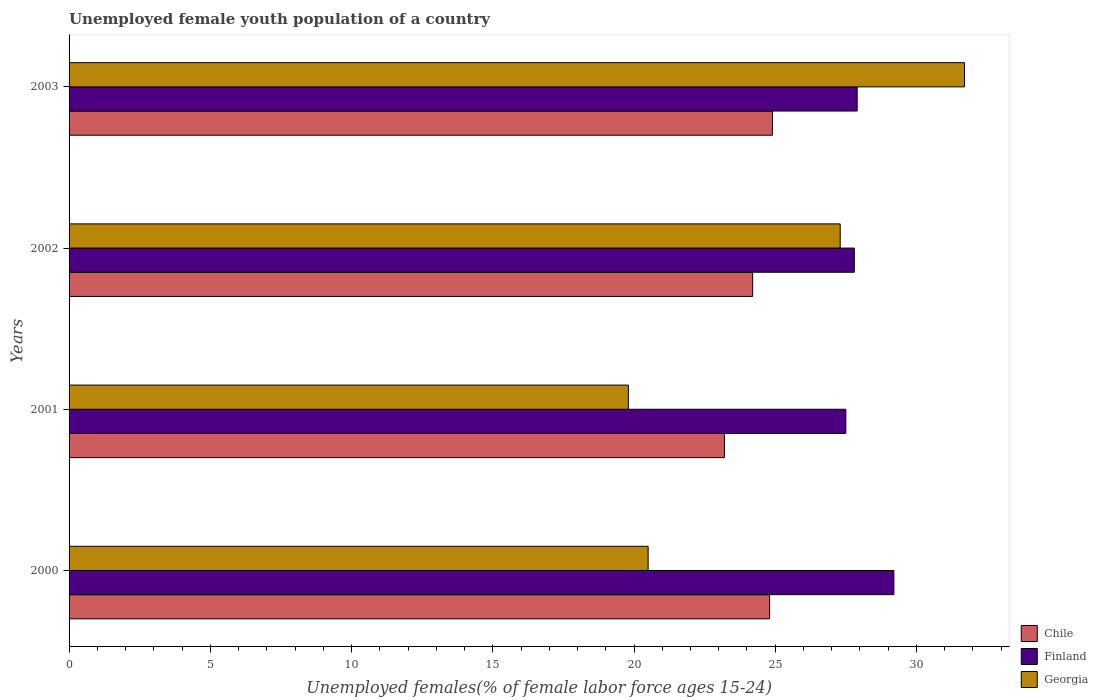How many different coloured bars are there?
Your answer should be compact. 3. How many groups of bars are there?
Ensure brevity in your answer.  4. Are the number of bars per tick equal to the number of legend labels?
Your response must be concise. Yes. In how many cases, is the number of bars for a given year not equal to the number of legend labels?
Provide a short and direct response. 0. What is the percentage of unemployed female youth population in Georgia in 2003?
Provide a succinct answer. 31.7. Across all years, what is the maximum percentage of unemployed female youth population in Finland?
Make the answer very short. 29.2. In which year was the percentage of unemployed female youth population in Chile maximum?
Your answer should be compact. 2003. In which year was the percentage of unemployed female youth population in Chile minimum?
Provide a succinct answer. 2001. What is the total percentage of unemployed female youth population in Chile in the graph?
Your answer should be very brief. 97.1. What is the difference between the percentage of unemployed female youth population in Georgia in 2000 and that in 2001?
Your response must be concise. 0.7. What is the difference between the percentage of unemployed female youth population in Finland in 2000 and the percentage of unemployed female youth population in Georgia in 2001?
Give a very brief answer. 9.4. What is the average percentage of unemployed female youth population in Finland per year?
Your answer should be compact. 28.1. In the year 2001, what is the difference between the percentage of unemployed female youth population in Georgia and percentage of unemployed female youth population in Finland?
Your answer should be compact. -7.7. In how many years, is the percentage of unemployed female youth population in Finland greater than 21 %?
Keep it short and to the point. 4. What is the ratio of the percentage of unemployed female youth population in Georgia in 2000 to that in 2002?
Keep it short and to the point. 0.75. Is the difference between the percentage of unemployed female youth population in Georgia in 2001 and 2003 greater than the difference between the percentage of unemployed female youth population in Finland in 2001 and 2003?
Keep it short and to the point. No. What is the difference between the highest and the second highest percentage of unemployed female youth population in Georgia?
Your answer should be compact. 4.4. What is the difference between the highest and the lowest percentage of unemployed female youth population in Finland?
Ensure brevity in your answer.  1.7. Is the sum of the percentage of unemployed female youth population in Chile in 2002 and 2003 greater than the maximum percentage of unemployed female youth population in Finland across all years?
Give a very brief answer. Yes. What does the 2nd bar from the top in 2002 represents?
Make the answer very short. Finland. Are all the bars in the graph horizontal?
Give a very brief answer. Yes. What is the difference between two consecutive major ticks on the X-axis?
Ensure brevity in your answer.  5. Where does the legend appear in the graph?
Make the answer very short. Bottom right. How many legend labels are there?
Your answer should be very brief. 3. What is the title of the graph?
Offer a very short reply. Unemployed female youth population of a country. Does "Middle East & North Africa (all income levels)" appear as one of the legend labels in the graph?
Ensure brevity in your answer.  No. What is the label or title of the X-axis?
Your answer should be very brief. Unemployed females(% of female labor force ages 15-24). What is the Unemployed females(% of female labor force ages 15-24) in Chile in 2000?
Offer a very short reply. 24.8. What is the Unemployed females(% of female labor force ages 15-24) in Finland in 2000?
Your response must be concise. 29.2. What is the Unemployed females(% of female labor force ages 15-24) of Chile in 2001?
Keep it short and to the point. 23.2. What is the Unemployed females(% of female labor force ages 15-24) of Finland in 2001?
Provide a succinct answer. 27.5. What is the Unemployed females(% of female labor force ages 15-24) in Georgia in 2001?
Your answer should be very brief. 19.8. What is the Unemployed females(% of female labor force ages 15-24) of Chile in 2002?
Your answer should be very brief. 24.2. What is the Unemployed females(% of female labor force ages 15-24) in Finland in 2002?
Your answer should be compact. 27.8. What is the Unemployed females(% of female labor force ages 15-24) of Georgia in 2002?
Keep it short and to the point. 27.3. What is the Unemployed females(% of female labor force ages 15-24) of Chile in 2003?
Provide a short and direct response. 24.9. What is the Unemployed females(% of female labor force ages 15-24) of Finland in 2003?
Your answer should be compact. 27.9. What is the Unemployed females(% of female labor force ages 15-24) of Georgia in 2003?
Your answer should be compact. 31.7. Across all years, what is the maximum Unemployed females(% of female labor force ages 15-24) of Chile?
Provide a short and direct response. 24.9. Across all years, what is the maximum Unemployed females(% of female labor force ages 15-24) in Finland?
Your answer should be very brief. 29.2. Across all years, what is the maximum Unemployed females(% of female labor force ages 15-24) in Georgia?
Keep it short and to the point. 31.7. Across all years, what is the minimum Unemployed females(% of female labor force ages 15-24) in Chile?
Keep it short and to the point. 23.2. Across all years, what is the minimum Unemployed females(% of female labor force ages 15-24) in Georgia?
Provide a short and direct response. 19.8. What is the total Unemployed females(% of female labor force ages 15-24) of Chile in the graph?
Make the answer very short. 97.1. What is the total Unemployed females(% of female labor force ages 15-24) of Finland in the graph?
Provide a short and direct response. 112.4. What is the total Unemployed females(% of female labor force ages 15-24) of Georgia in the graph?
Give a very brief answer. 99.3. What is the difference between the Unemployed females(% of female labor force ages 15-24) of Finland in 2000 and that in 2001?
Give a very brief answer. 1.7. What is the difference between the Unemployed females(% of female labor force ages 15-24) in Georgia in 2000 and that in 2003?
Ensure brevity in your answer.  -11.2. What is the difference between the Unemployed females(% of female labor force ages 15-24) of Georgia in 2001 and that in 2002?
Make the answer very short. -7.5. What is the difference between the Unemployed females(% of female labor force ages 15-24) in Chile in 2000 and the Unemployed females(% of female labor force ages 15-24) in Finland in 2001?
Make the answer very short. -2.7. What is the difference between the Unemployed females(% of female labor force ages 15-24) in Chile in 2000 and the Unemployed females(% of female labor force ages 15-24) in Finland in 2002?
Make the answer very short. -3. What is the difference between the Unemployed females(% of female labor force ages 15-24) of Chile in 2000 and the Unemployed females(% of female labor force ages 15-24) of Georgia in 2002?
Offer a very short reply. -2.5. What is the difference between the Unemployed females(% of female labor force ages 15-24) in Finland in 2000 and the Unemployed females(% of female labor force ages 15-24) in Georgia in 2002?
Keep it short and to the point. 1.9. What is the difference between the Unemployed females(% of female labor force ages 15-24) in Chile in 2000 and the Unemployed females(% of female labor force ages 15-24) in Georgia in 2003?
Your response must be concise. -6.9. What is the difference between the Unemployed females(% of female labor force ages 15-24) of Chile in 2001 and the Unemployed females(% of female labor force ages 15-24) of Georgia in 2002?
Offer a very short reply. -4.1. What is the difference between the Unemployed females(% of female labor force ages 15-24) in Chile in 2001 and the Unemployed females(% of female labor force ages 15-24) in Georgia in 2003?
Offer a very short reply. -8.5. What is the difference between the Unemployed females(% of female labor force ages 15-24) of Chile in 2002 and the Unemployed females(% of female labor force ages 15-24) of Georgia in 2003?
Offer a very short reply. -7.5. What is the difference between the Unemployed females(% of female labor force ages 15-24) in Finland in 2002 and the Unemployed females(% of female labor force ages 15-24) in Georgia in 2003?
Make the answer very short. -3.9. What is the average Unemployed females(% of female labor force ages 15-24) in Chile per year?
Your answer should be very brief. 24.27. What is the average Unemployed females(% of female labor force ages 15-24) in Finland per year?
Provide a succinct answer. 28.1. What is the average Unemployed females(% of female labor force ages 15-24) of Georgia per year?
Ensure brevity in your answer.  24.82. In the year 2000, what is the difference between the Unemployed females(% of female labor force ages 15-24) of Chile and Unemployed females(% of female labor force ages 15-24) of Finland?
Your answer should be very brief. -4.4. In the year 2000, what is the difference between the Unemployed females(% of female labor force ages 15-24) of Chile and Unemployed females(% of female labor force ages 15-24) of Georgia?
Give a very brief answer. 4.3. In the year 2001, what is the difference between the Unemployed females(% of female labor force ages 15-24) in Chile and Unemployed females(% of female labor force ages 15-24) in Finland?
Provide a succinct answer. -4.3. In the year 2001, what is the difference between the Unemployed females(% of female labor force ages 15-24) of Finland and Unemployed females(% of female labor force ages 15-24) of Georgia?
Ensure brevity in your answer.  7.7. In the year 2003, what is the difference between the Unemployed females(% of female labor force ages 15-24) of Finland and Unemployed females(% of female labor force ages 15-24) of Georgia?
Your response must be concise. -3.8. What is the ratio of the Unemployed females(% of female labor force ages 15-24) of Chile in 2000 to that in 2001?
Provide a short and direct response. 1.07. What is the ratio of the Unemployed females(% of female labor force ages 15-24) of Finland in 2000 to that in 2001?
Provide a succinct answer. 1.06. What is the ratio of the Unemployed females(% of female labor force ages 15-24) of Georgia in 2000 to that in 2001?
Make the answer very short. 1.04. What is the ratio of the Unemployed females(% of female labor force ages 15-24) in Chile in 2000 to that in 2002?
Ensure brevity in your answer.  1.02. What is the ratio of the Unemployed females(% of female labor force ages 15-24) in Finland in 2000 to that in 2002?
Ensure brevity in your answer.  1.05. What is the ratio of the Unemployed females(% of female labor force ages 15-24) of Georgia in 2000 to that in 2002?
Your answer should be very brief. 0.75. What is the ratio of the Unemployed females(% of female labor force ages 15-24) of Finland in 2000 to that in 2003?
Give a very brief answer. 1.05. What is the ratio of the Unemployed females(% of female labor force ages 15-24) in Georgia in 2000 to that in 2003?
Your response must be concise. 0.65. What is the ratio of the Unemployed females(% of female labor force ages 15-24) in Chile in 2001 to that in 2002?
Provide a short and direct response. 0.96. What is the ratio of the Unemployed females(% of female labor force ages 15-24) in Georgia in 2001 to that in 2002?
Your answer should be compact. 0.73. What is the ratio of the Unemployed females(% of female labor force ages 15-24) in Chile in 2001 to that in 2003?
Your answer should be very brief. 0.93. What is the ratio of the Unemployed females(% of female labor force ages 15-24) of Finland in 2001 to that in 2003?
Give a very brief answer. 0.99. What is the ratio of the Unemployed females(% of female labor force ages 15-24) in Georgia in 2001 to that in 2003?
Offer a very short reply. 0.62. What is the ratio of the Unemployed females(% of female labor force ages 15-24) in Chile in 2002 to that in 2003?
Give a very brief answer. 0.97. What is the ratio of the Unemployed females(% of female labor force ages 15-24) of Finland in 2002 to that in 2003?
Offer a very short reply. 1. What is the ratio of the Unemployed females(% of female labor force ages 15-24) of Georgia in 2002 to that in 2003?
Offer a very short reply. 0.86. What is the difference between the highest and the second highest Unemployed females(% of female labor force ages 15-24) of Chile?
Give a very brief answer. 0.1. What is the difference between the highest and the second highest Unemployed females(% of female labor force ages 15-24) of Finland?
Ensure brevity in your answer.  1.3. What is the difference between the highest and the lowest Unemployed females(% of female labor force ages 15-24) in Chile?
Provide a succinct answer. 1.7. What is the difference between the highest and the lowest Unemployed females(% of female labor force ages 15-24) of Georgia?
Keep it short and to the point. 11.9. 